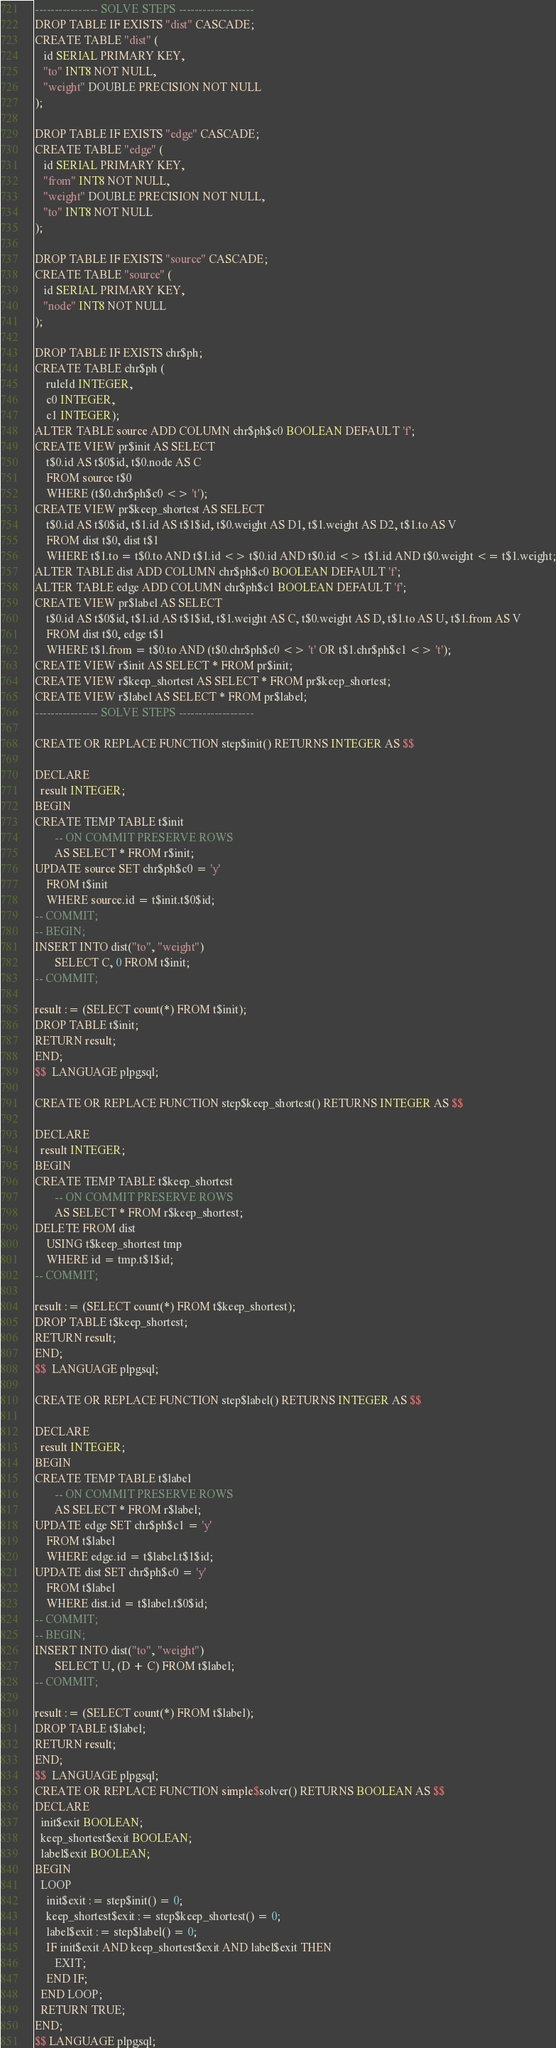Convert code to text. <code><loc_0><loc_0><loc_500><loc_500><_SQL_>
---------------- SOLVE STEPS -------------------
DROP TABLE IF EXISTS "dist" CASCADE;
CREATE TABLE "dist" (
   id SERIAL PRIMARY KEY,
   "to" INT8 NOT NULL,
   "weight" DOUBLE PRECISION NOT NULL
);

DROP TABLE IF EXISTS "edge" CASCADE;
CREATE TABLE "edge" (
   id SERIAL PRIMARY KEY,
   "from" INT8 NOT NULL,
   "weight" DOUBLE PRECISION NOT NULL,
   "to" INT8 NOT NULL
);

DROP TABLE IF EXISTS "source" CASCADE;
CREATE TABLE "source" (
   id SERIAL PRIMARY KEY,
   "node" INT8 NOT NULL
);

DROP TABLE IF EXISTS chr$ph;
CREATE TABLE chr$ph (
    ruleId INTEGER,
    c0 INTEGER,
    c1 INTEGER);
ALTER TABLE source ADD COLUMN chr$ph$c0 BOOLEAN DEFAULT 'f';
CREATE VIEW pr$init AS SELECT
	t$0.id AS t$0$id, t$0.node AS C
	FROM source t$0
	WHERE (t$0.chr$ph$c0 <> 't');
CREATE VIEW pr$keep_shortest AS SELECT
	t$0.id AS t$0$id, t$1.id AS t$1$id, t$0.weight AS D1, t$1.weight AS D2, t$1.to AS V
	FROM dist t$0, dist t$1
	WHERE t$1.to = t$0.to AND t$1.id <> t$0.id AND t$0.id <> t$1.id AND t$0.weight <= t$1.weight;
ALTER TABLE dist ADD COLUMN chr$ph$c0 BOOLEAN DEFAULT 'f';
ALTER TABLE edge ADD COLUMN chr$ph$c1 BOOLEAN DEFAULT 'f';
CREATE VIEW pr$label AS SELECT
	t$0.id AS t$0$id, t$1.id AS t$1$id, t$1.weight AS C, t$0.weight AS D, t$1.to AS U, t$1.from AS V
	FROM dist t$0, edge t$1
	WHERE t$1.from = t$0.to AND (t$0.chr$ph$c0 <> 't' OR t$1.chr$ph$c1 <> 't');
CREATE VIEW r$init AS SELECT * FROM pr$init;
CREATE VIEW r$keep_shortest AS SELECT * FROM pr$keep_shortest;
CREATE VIEW r$label AS SELECT * FROM pr$label;
---------------- SOLVE STEPS -------------------

CREATE OR REPLACE FUNCTION step$init() RETURNS INTEGER AS $$

DECLARE
  result INTEGER;
BEGIN
CREATE TEMP TABLE t$init
       -- ON COMMIT PRESERVE ROWS
       AS SELECT * FROM r$init;
UPDATE source SET chr$ph$c0 = 'y' 
    FROM t$init
    WHERE source.id = t$init.t$0$id;
-- COMMIT;
-- BEGIN;
INSERT INTO dist("to", "weight") 
       SELECT C, 0 FROM t$init;
-- COMMIT;

result := (SELECT count(*) FROM t$init);
DROP TABLE t$init;
RETURN result;
END;
$$  LANGUAGE plpgsql;

CREATE OR REPLACE FUNCTION step$keep_shortest() RETURNS INTEGER AS $$

DECLARE
  result INTEGER;
BEGIN
CREATE TEMP TABLE t$keep_shortest
       -- ON COMMIT PRESERVE ROWS
       AS SELECT * FROM r$keep_shortest;
DELETE FROM dist
    USING t$keep_shortest tmp
    WHERE id = tmp.t$1$id;
-- COMMIT;

result := (SELECT count(*) FROM t$keep_shortest);
DROP TABLE t$keep_shortest;
RETURN result;
END;
$$  LANGUAGE plpgsql;

CREATE OR REPLACE FUNCTION step$label() RETURNS INTEGER AS $$

DECLARE
  result INTEGER;
BEGIN
CREATE TEMP TABLE t$label
       -- ON COMMIT PRESERVE ROWS
       AS SELECT * FROM r$label;
UPDATE edge SET chr$ph$c1 = 'y' 
    FROM t$label
    WHERE edge.id = t$label.t$1$id;
UPDATE dist SET chr$ph$c0 = 'y' 
    FROM t$label
    WHERE dist.id = t$label.t$0$id;
-- COMMIT;
-- BEGIN;
INSERT INTO dist("to", "weight") 
       SELECT U, (D + C) FROM t$label;
-- COMMIT;

result := (SELECT count(*) FROM t$label);
DROP TABLE t$label;
RETURN result;
END;
$$  LANGUAGE plpgsql;
CREATE OR REPLACE FUNCTION simple$solver() RETURNS BOOLEAN AS $$
DECLARE
  init$exit BOOLEAN;
  keep_shortest$exit BOOLEAN;
  label$exit BOOLEAN;
BEGIN
  LOOP
    init$exit := step$init() = 0;
    keep_shortest$exit := step$keep_shortest() = 0;
    label$exit := step$label() = 0;
    IF init$exit AND keep_shortest$exit AND label$exit THEN
       EXIT;
    END IF;
  END LOOP;
  RETURN TRUE;
END;
$$ LANGUAGE plpgsql;
</code> 